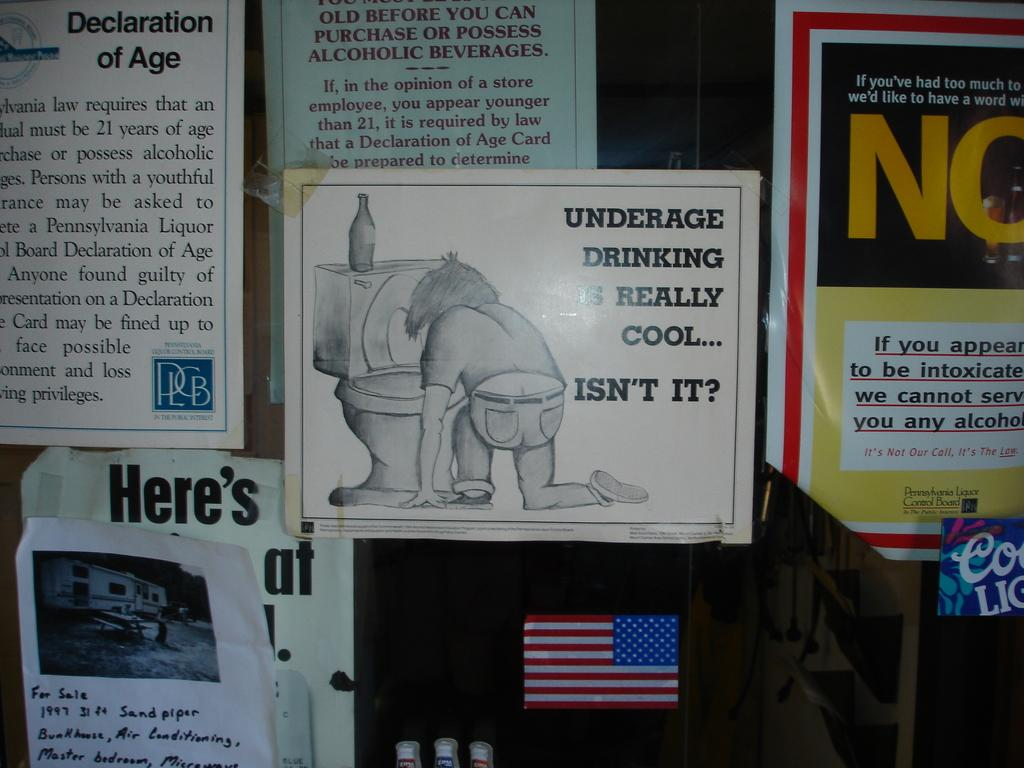Provide a one-sentence caption for the provided image. Various posters and fliers are on a wall, including one asking if underage drinking is really cool. 